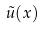Convert formula to latex. <formula><loc_0><loc_0><loc_500><loc_500>\tilde { u } ( x )</formula> 